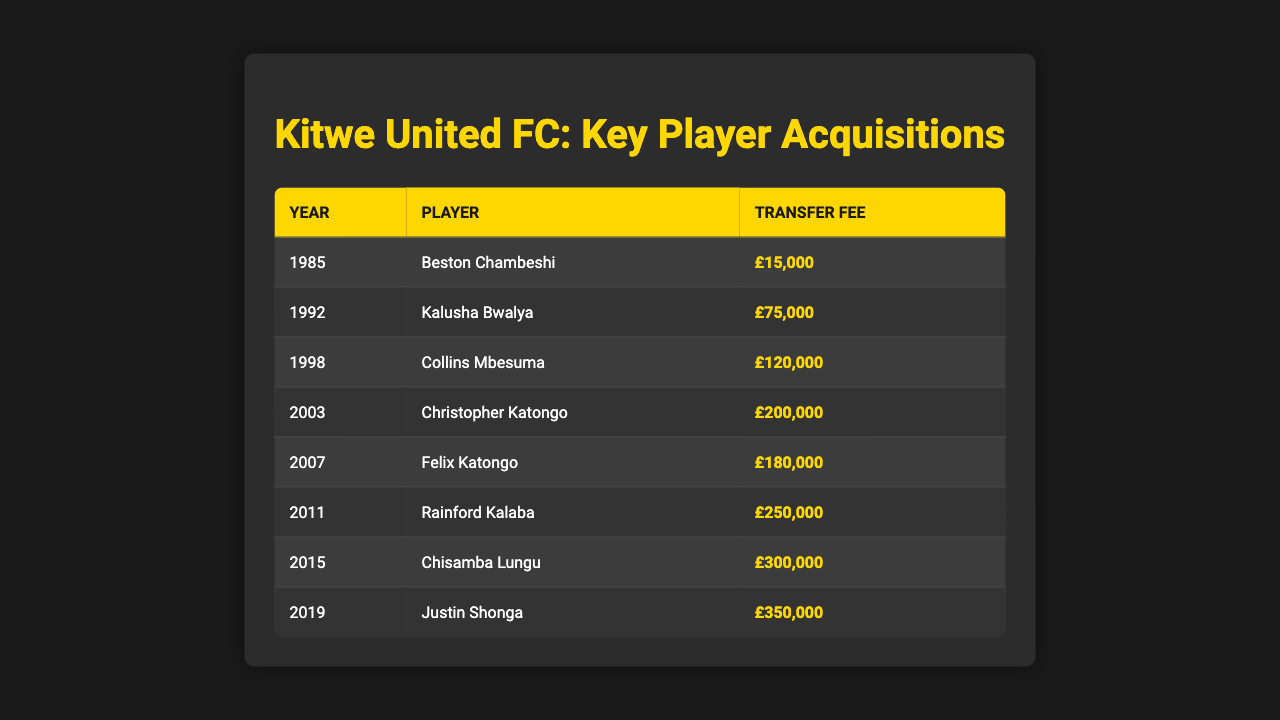What player had the highest transfer fee? By scanning the 'Transfer Fee' column, the highest value listed is £350,000, which corresponds to Justin Shonga.
Answer: Justin Shonga In what year was Rainford Kalaba acquired? The table indicates that Rainford Kalaba was acquired in 2011, which is directly indicated in the 'Year' column next to his name.
Answer: 2011 What is the total transfer fee paid for the players between 2000 and 2010? To find the total transfer fee for this range, we add the fees from 2003, 2007, and 2011: £200,000 + £180,000 + £250,000 = £630,000.
Answer: £630,000 How many players were acquired in the 1990s? The table shows one player, Kalusha Bwalya, acquired in 1992, and Collins Mbesuma was acquired in 1998, totaling two players during this decade.
Answer: 2 What was the average transfer fee for players acquired before 2000? The transfer fees before 2000 are £15,000 (1985), £75,000 (1992), and £120,000 (1998). The average is calculated as (15,000 + 75,000 + 120,000) / 3 = £70,000.
Answer: £70,000 Which year saw the largest increase in transfer fee compared to the previous year? By comparing the 'Transfer Fee' values year-over-year: from 2015 to 2019, the increase from £300,000 to £350,000 is £50,000, which is the largest increase.
Answer: £50,000 Did Kitwe United FC pay over £300,000 for more than one player? Examining the 'Transfer Fee' column, only one player, Justin Shonga (2019), has a fee over £300,000, indicating the answer is no.
Answer: No What was the trend in transfer fees for Kitwe United FC from the 1980s to the 2010s? Observing the table, it is clear that transfer fees have generally increased over the decades, starting from £15,000 in the 1980s and reaching £350,000 in the 2010s.
Answer: Increasing trend 